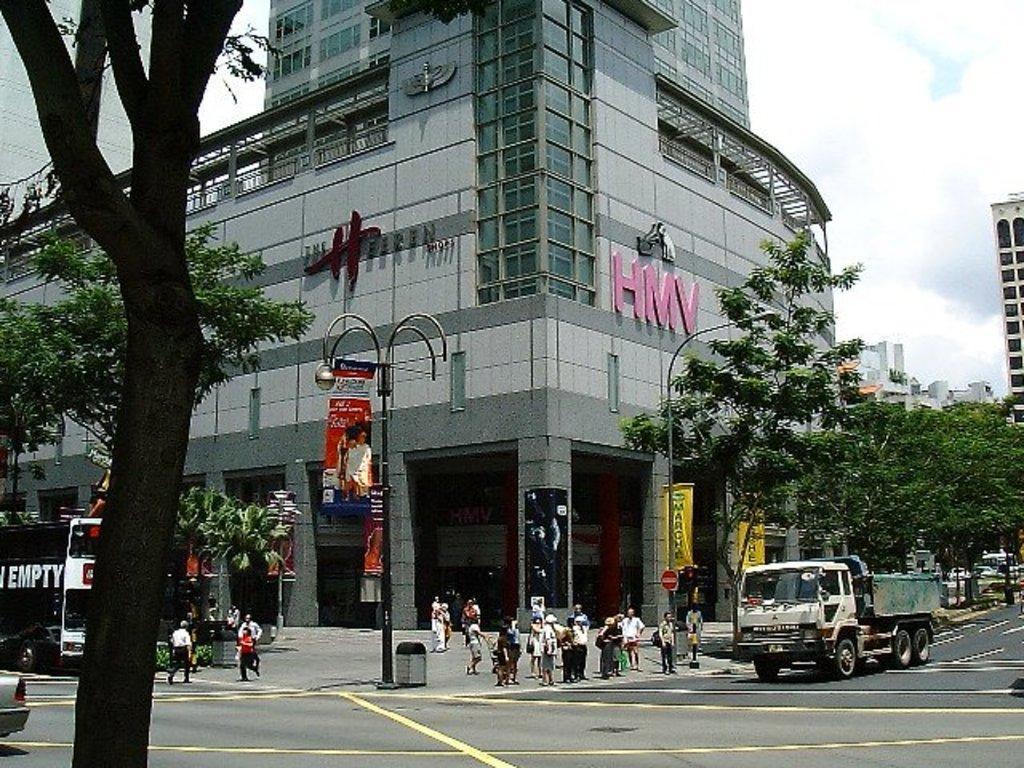In one or two sentences, can you explain what this image depicts? In this image we can see a few buildings, there are some trees, poles, vehicles, lights, people and posters with some text and images, also we can see the sky with clouds. 